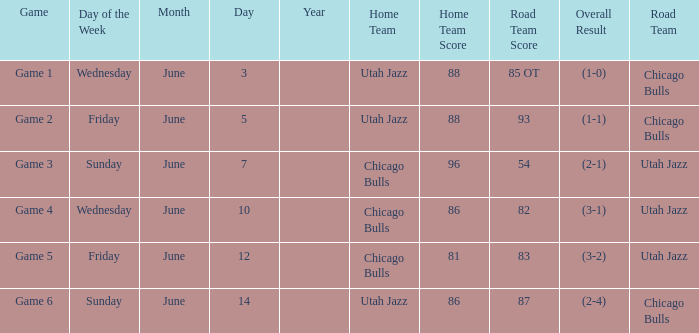Game of game 5 had what result? 81-83 (3-2). 